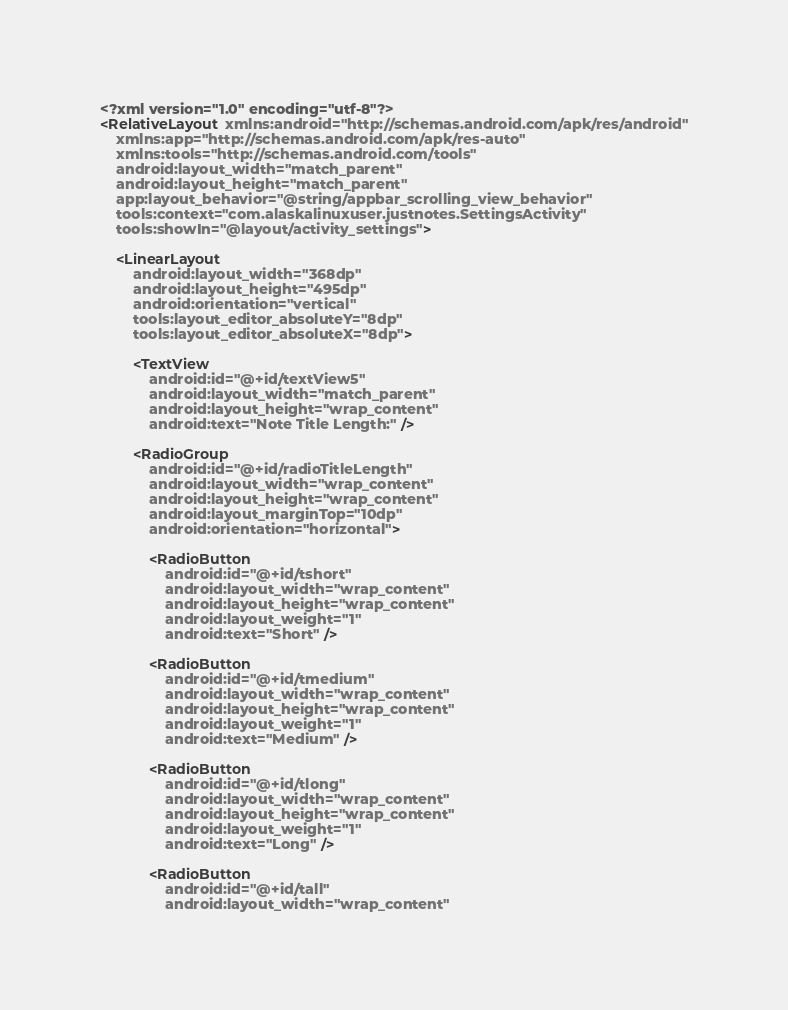Convert code to text. <code><loc_0><loc_0><loc_500><loc_500><_XML_><?xml version="1.0" encoding="utf-8"?>
<RelativeLayout xmlns:android="http://schemas.android.com/apk/res/android"
    xmlns:app="http://schemas.android.com/apk/res-auto"
    xmlns:tools="http://schemas.android.com/tools"
    android:layout_width="match_parent"
    android:layout_height="match_parent"
    app:layout_behavior="@string/appbar_scrolling_view_behavior"
    tools:context="com.alaskalinuxuser.justnotes.SettingsActivity"
    tools:showIn="@layout/activity_settings">

    <LinearLayout
        android:layout_width="368dp"
        android:layout_height="495dp"
        android:orientation="vertical"
        tools:layout_editor_absoluteY="8dp"
        tools:layout_editor_absoluteX="8dp">

        <TextView
            android:id="@+id/textView5"
            android:layout_width="match_parent"
            android:layout_height="wrap_content"
            android:text="Note Title Length:" />

        <RadioGroup
            android:id="@+id/radioTitleLength"
            android:layout_width="wrap_content"
            android:layout_height="wrap_content"
            android:layout_marginTop="10dp"
            android:orientation="horizontal">

            <RadioButton
                android:id="@+id/tshort"
                android:layout_width="wrap_content"
                android:layout_height="wrap_content"
                android:layout_weight="1"
                android:text="Short" />

            <RadioButton
                android:id="@+id/tmedium"
                android:layout_width="wrap_content"
                android:layout_height="wrap_content"
                android:layout_weight="1"
                android:text="Medium" />

            <RadioButton
                android:id="@+id/tlong"
                android:layout_width="wrap_content"
                android:layout_height="wrap_content"
                android:layout_weight="1"
                android:text="Long" />

            <RadioButton
                android:id="@+id/tall"
                android:layout_width="wrap_content"</code> 